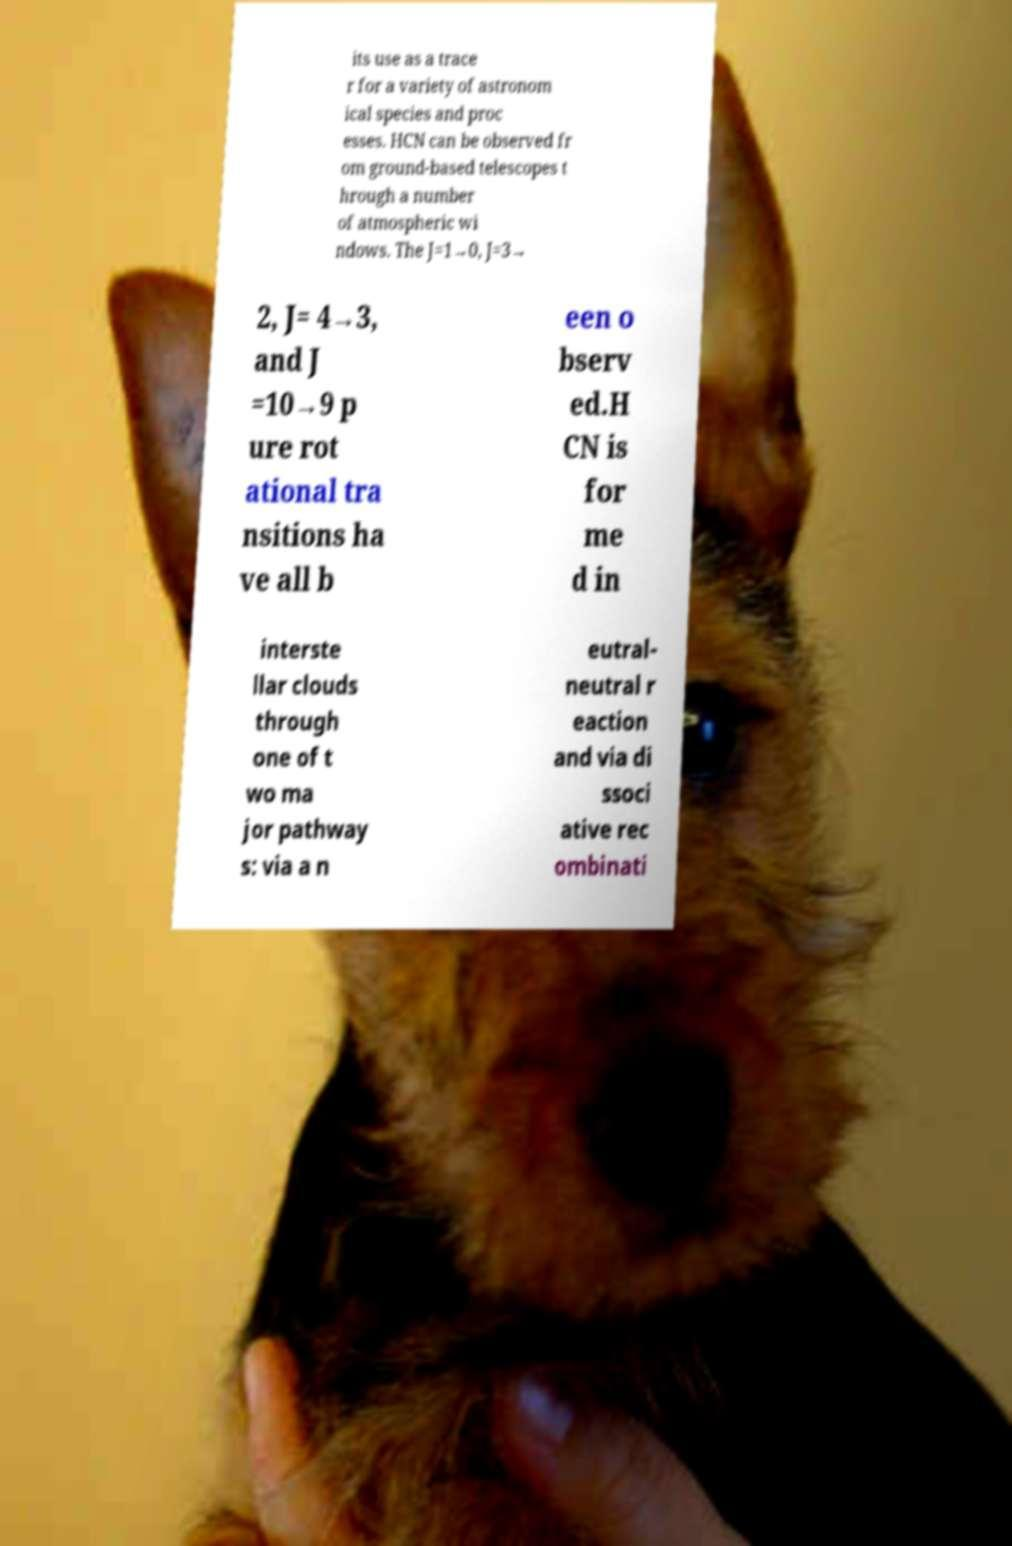Can you accurately transcribe the text from the provided image for me? its use as a trace r for a variety of astronom ical species and proc esses. HCN can be observed fr om ground-based telescopes t hrough a number of atmospheric wi ndows. The J=1→0, J=3→ 2, J= 4→3, and J =10→9 p ure rot ational tra nsitions ha ve all b een o bserv ed.H CN is for me d in interste llar clouds through one of t wo ma jor pathway s: via a n eutral- neutral r eaction and via di ssoci ative rec ombinati 